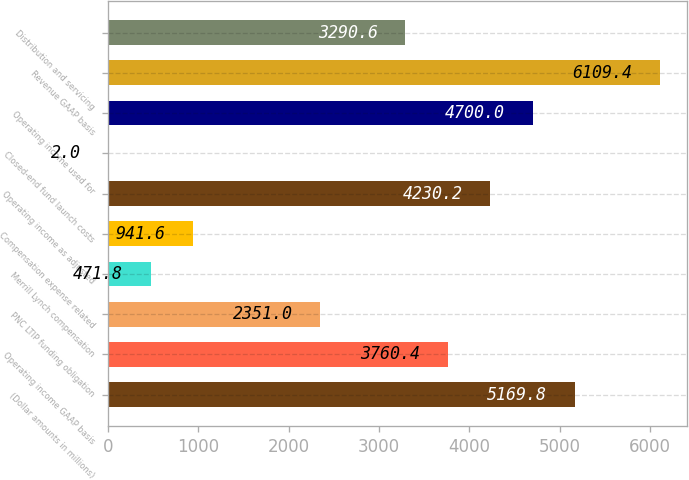Convert chart. <chart><loc_0><loc_0><loc_500><loc_500><bar_chart><fcel>(Dollar amounts in millions)<fcel>Operating income GAAP basis<fcel>PNC LTIP funding obligation<fcel>Merrill Lynch compensation<fcel>Compensation expense related<fcel>Operating income as adjusted<fcel>Closed-end fund launch costs<fcel>Operating income used for<fcel>Revenue GAAP basis<fcel>Distribution and servicing<nl><fcel>5169.8<fcel>3760.4<fcel>2351<fcel>471.8<fcel>941.6<fcel>4230.2<fcel>2<fcel>4700<fcel>6109.4<fcel>3290.6<nl></chart> 